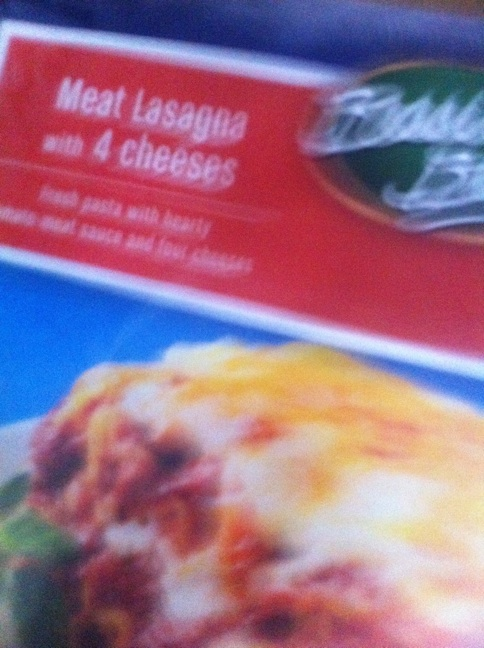Is this lasagna suitable for vegetarians? The lasagna is labeled as 'Meat Lasagna,' which indicates that it contains meat. Therefore, it is not suitable for vegetarians. 